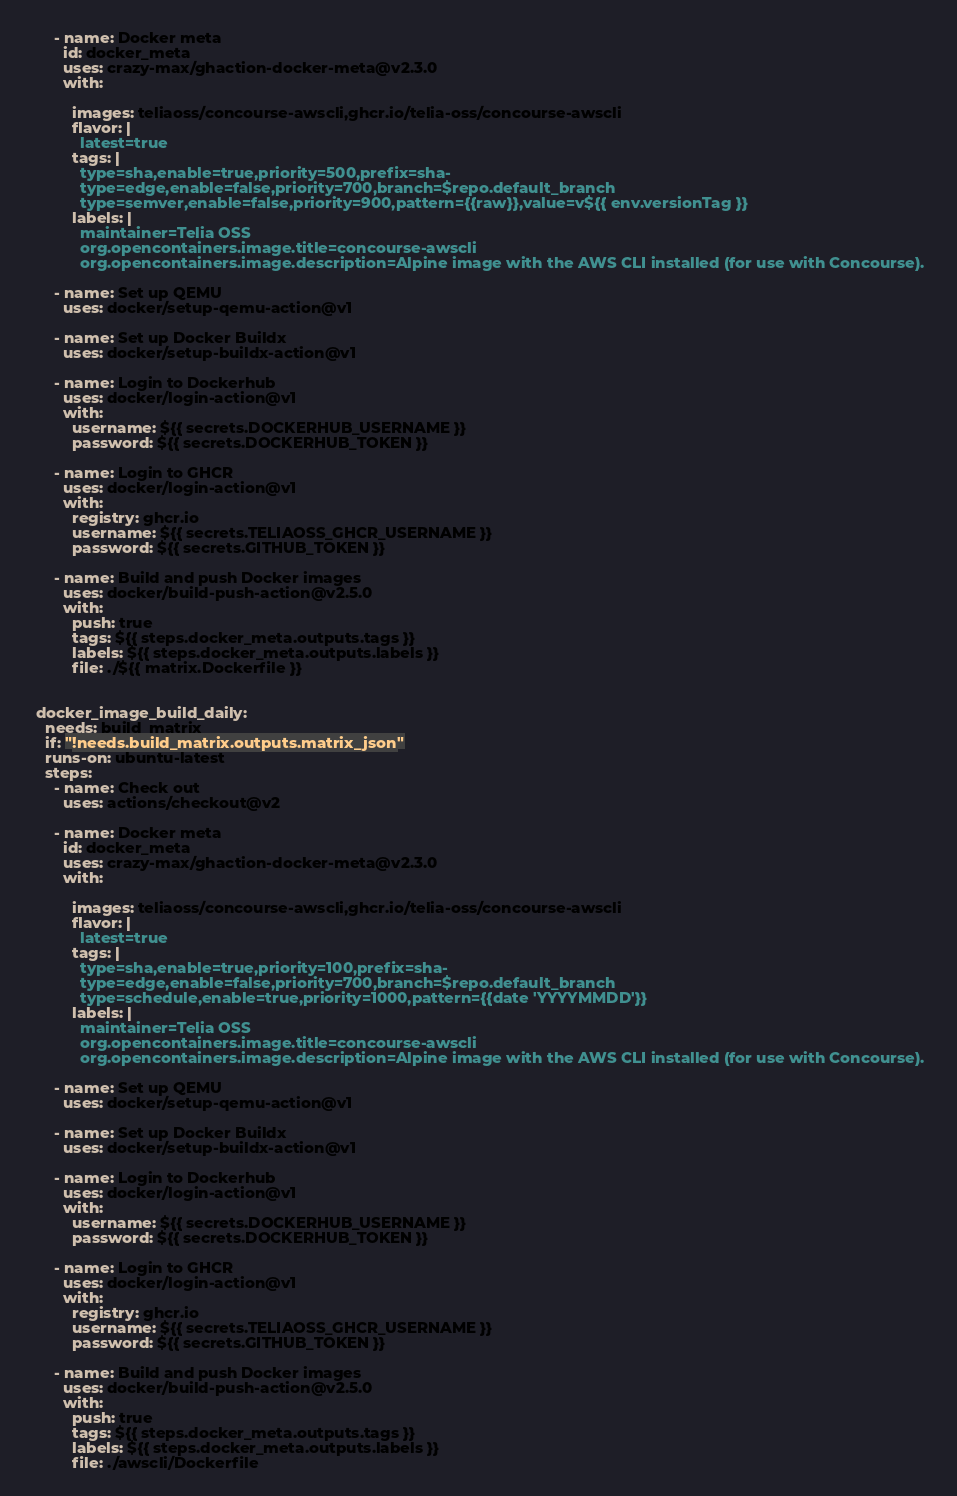<code> <loc_0><loc_0><loc_500><loc_500><_YAML_>

      - name: Docker meta
        id: docker_meta
        uses: crazy-max/ghaction-docker-meta@v2.3.0
        with:
          
          images: teliaoss/concourse-awscli,ghcr.io/telia-oss/concourse-awscli
          flavor: |
            latest=true
          tags: |
            type=sha,enable=true,priority=500,prefix=sha-
            type=edge,enable=false,priority=700,branch=$repo.default_branch
            type=semver,enable=false,priority=900,pattern={{raw}},value=v${{ env.versionTag }}    
          labels: |
            maintainer=Telia OSS
            org.opencontainers.image.title=concourse-awscli
            org.opencontainers.image.description=Alpine image with the AWS CLI installed (for use with Concourse). 

      - name: Set up QEMU
        uses: docker/setup-qemu-action@v1

      - name: Set up Docker Buildx
        uses: docker/setup-buildx-action@v1
        
      - name: Login to Dockerhub
        uses: docker/login-action@v1
        with:
          username: ${{ secrets.DOCKERHUB_USERNAME }}
          password: ${{ secrets.DOCKERHUB_TOKEN }}

      - name: Login to GHCR
        uses: docker/login-action@v1
        with:
          registry: ghcr.io
          username: ${{ secrets.TELIAOSS_GHCR_USERNAME }}
          password: ${{ secrets.GITHUB_TOKEN }}  
          
      - name: Build and push Docker images
        uses: docker/build-push-action@v2.5.0
        with:
          push: true
          tags: ${{ steps.docker_meta.outputs.tags }}
          labels: ${{ steps.docker_meta.outputs.labels }} 
          file: ./${{ matrix.Dockerfile }} 


  docker_image_build_daily:
    needs: build_matrix
    if: "!needs.build_matrix.outputs.matrix_json"
    runs-on: ubuntu-latest
    steps: 
      - name: Check out
        uses: actions/checkout@v2

      - name: Docker meta
        id: docker_meta
        uses: crazy-max/ghaction-docker-meta@v2.3.0
        with:
          
          images: teliaoss/concourse-awscli,ghcr.io/telia-oss/concourse-awscli
          flavor: |
            latest=true
          tags: |
            type=sha,enable=true,priority=100,prefix=sha-
            type=edge,enable=false,priority=700,branch=$repo.default_branch
            type=schedule,enable=true,priority=1000,pattern={{date 'YYYYMMDD'}}    
          labels: |
            maintainer=Telia OSS
            org.opencontainers.image.title=concourse-awscli
            org.opencontainers.image.description=Alpine image with the AWS CLI installed (for use with Concourse). 

      - name: Set up QEMU
        uses: docker/setup-qemu-action@v1

      - name: Set up Docker Buildx
        uses: docker/setup-buildx-action@v1
        
      - name: Login to Dockerhub
        uses: docker/login-action@v1
        with:
          username: ${{ secrets.DOCKERHUB_USERNAME }}
          password: ${{ secrets.DOCKERHUB_TOKEN }}

      - name: Login to GHCR
        uses: docker/login-action@v1
        with:
          registry: ghcr.io
          username: ${{ secrets.TELIAOSS_GHCR_USERNAME }}
          password: ${{ secrets.GITHUB_TOKEN }}    
          
      - name: Build and push Docker images
        uses: docker/build-push-action@v2.5.0
        with:
          push: true
          tags: ${{ steps.docker_meta.outputs.tags }}
          labels: ${{ steps.docker_meta.outputs.labels }} 
          file: ./awscli/Dockerfile           
</code> 